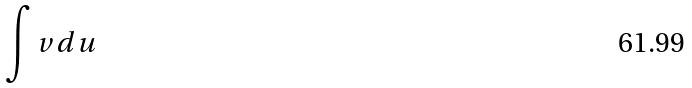<formula> <loc_0><loc_0><loc_500><loc_500>\int v d u</formula> 